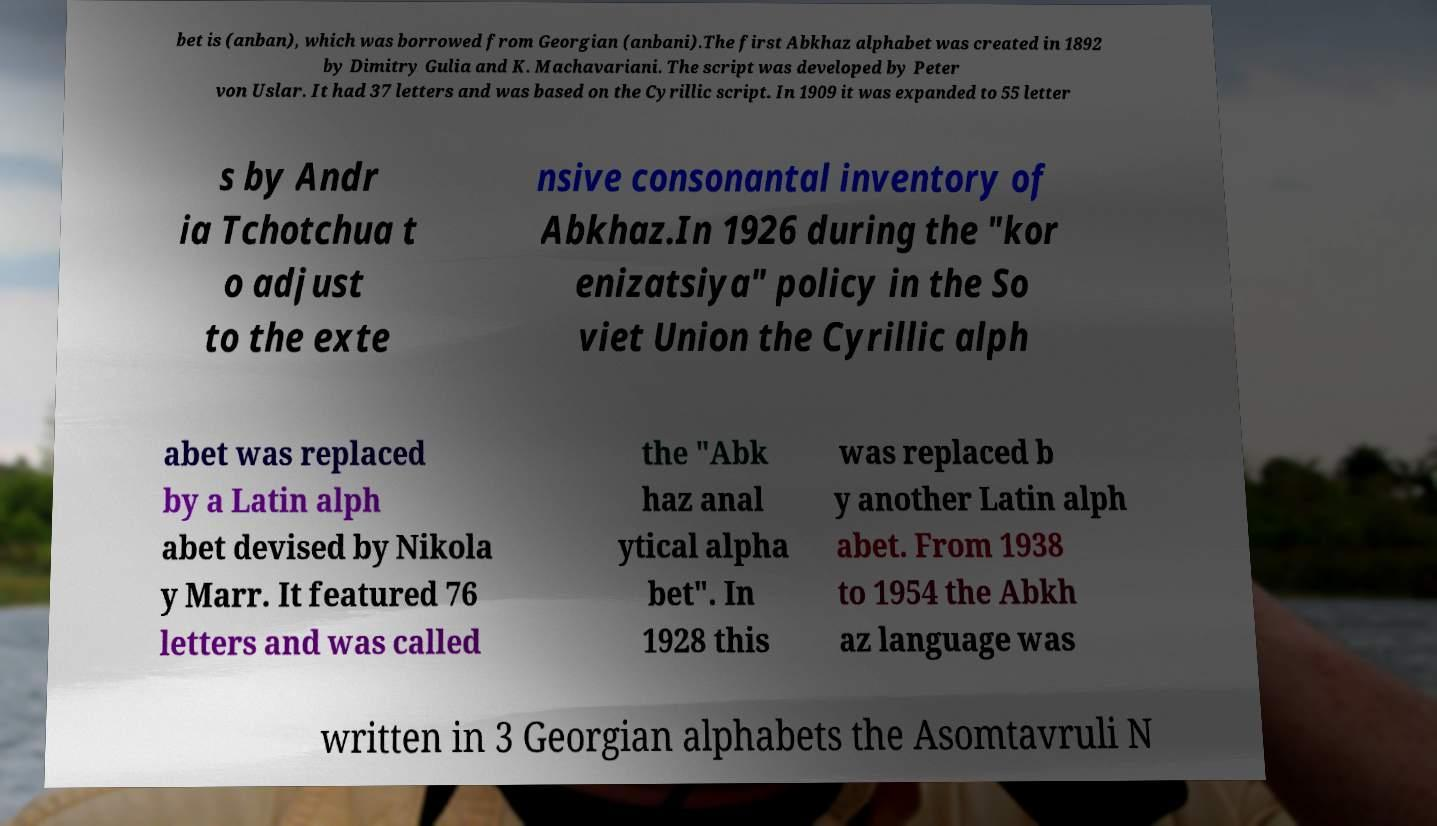Could you extract and type out the text from this image? bet is (anban), which was borrowed from Georgian (anbani).The first Abkhaz alphabet was created in 1892 by Dimitry Gulia and K. Machavariani. The script was developed by Peter von Uslar. It had 37 letters and was based on the Cyrillic script. In 1909 it was expanded to 55 letter s by Andr ia Tchotchua t o adjust to the exte nsive consonantal inventory of Abkhaz.In 1926 during the "kor enizatsiya" policy in the So viet Union the Cyrillic alph abet was replaced by a Latin alph abet devised by Nikola y Marr. It featured 76 letters and was called the "Abk haz anal ytical alpha bet". In 1928 this was replaced b y another Latin alph abet. From 1938 to 1954 the Abkh az language was written in 3 Georgian alphabets the Asomtavruli N 